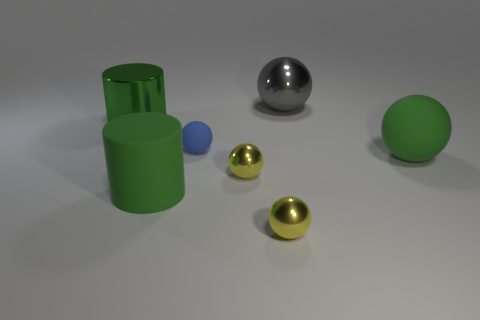What material is the small yellow object left of the ball in front of the green matte cylinder?
Offer a terse response. Metal. How many objects are either large green objects that are to the right of the gray metal thing or big objects behind the blue object?
Provide a short and direct response. 3. How big is the cylinder that is behind the big green cylinder that is in front of the ball on the right side of the gray metal ball?
Keep it short and to the point. Large. Are there the same number of big green metal things left of the big green metallic thing and big purple shiny cylinders?
Your response must be concise. Yes. Do the gray thing and the green object right of the tiny blue rubber ball have the same shape?
Your response must be concise. Yes. The gray shiny object that is the same shape as the blue thing is what size?
Ensure brevity in your answer.  Large. How many other things are there of the same material as the gray thing?
Ensure brevity in your answer.  3. What is the big gray ball made of?
Give a very brief answer. Metal. There is a big cylinder behind the tiny matte sphere; is its color the same as the cylinder that is in front of the small blue ball?
Ensure brevity in your answer.  Yes. Are there more matte things that are on the right side of the gray metallic thing than blue metallic objects?
Provide a short and direct response. Yes. 